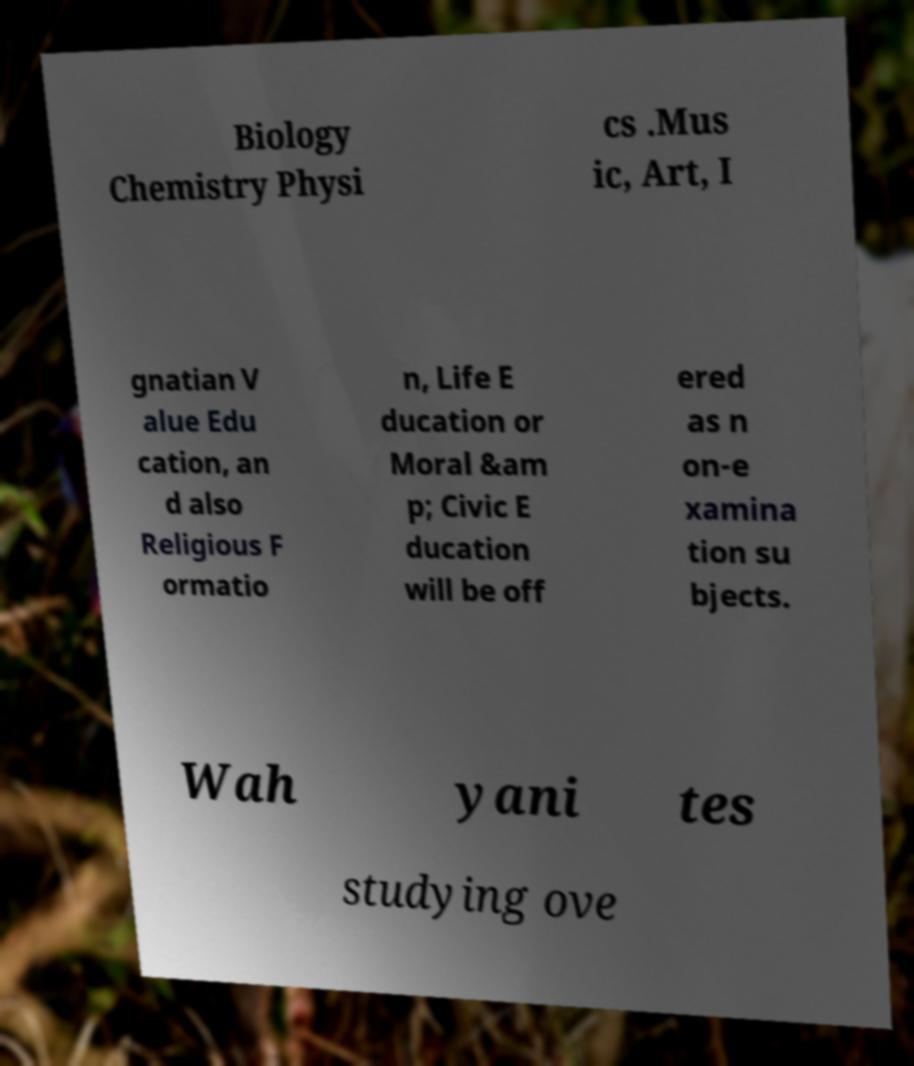Please read and relay the text visible in this image. What does it say? Biology Chemistry Physi cs .Mus ic, Art, I gnatian V alue Edu cation, an d also Religious F ormatio n, Life E ducation or Moral &am p; Civic E ducation will be off ered as n on-e xamina tion su bjects. Wah yani tes studying ove 